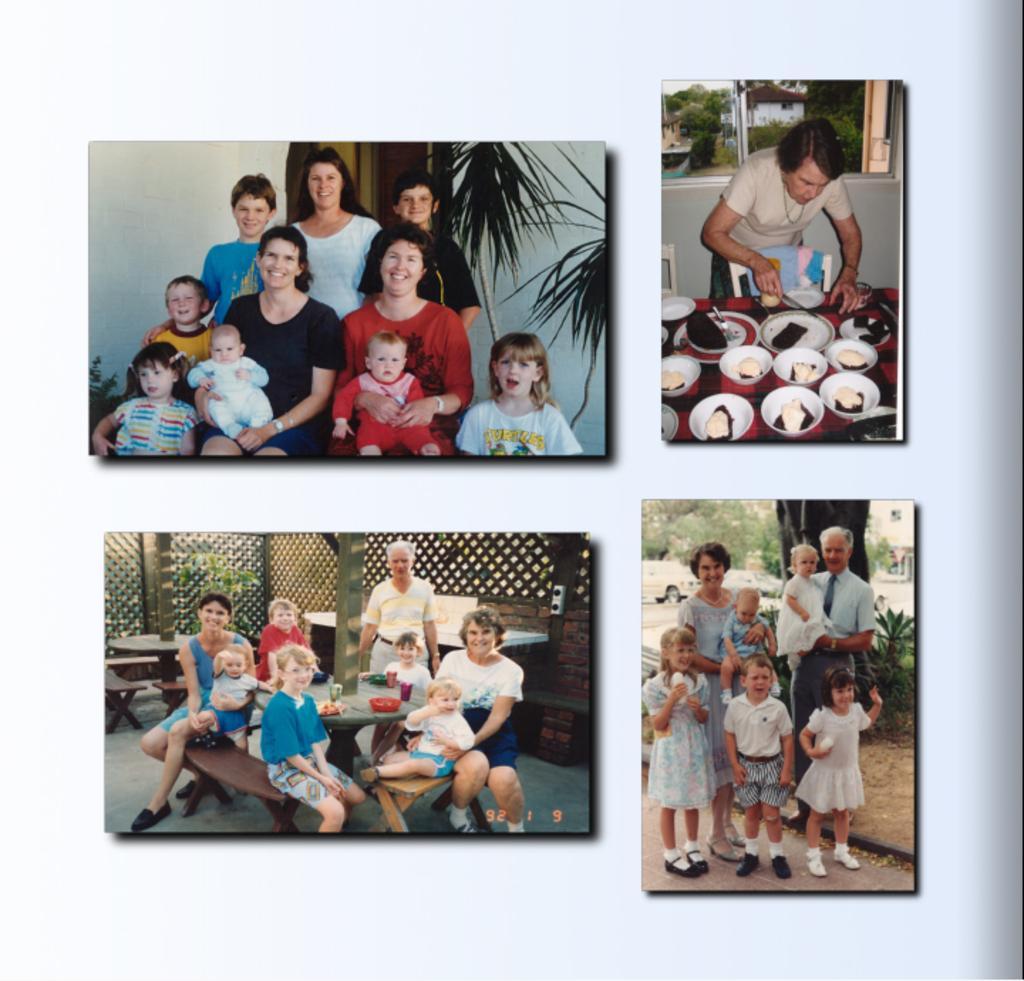Please provide a concise description of this image. This is an edited image. I can see four photos of people. On the right side of the image, I can see a group of people and a person standing. On the left side of the image, I can see groups of people sitting on the benches and smiling. There are trees, plants, vehicles, tables, benches and food items in the bowls. 